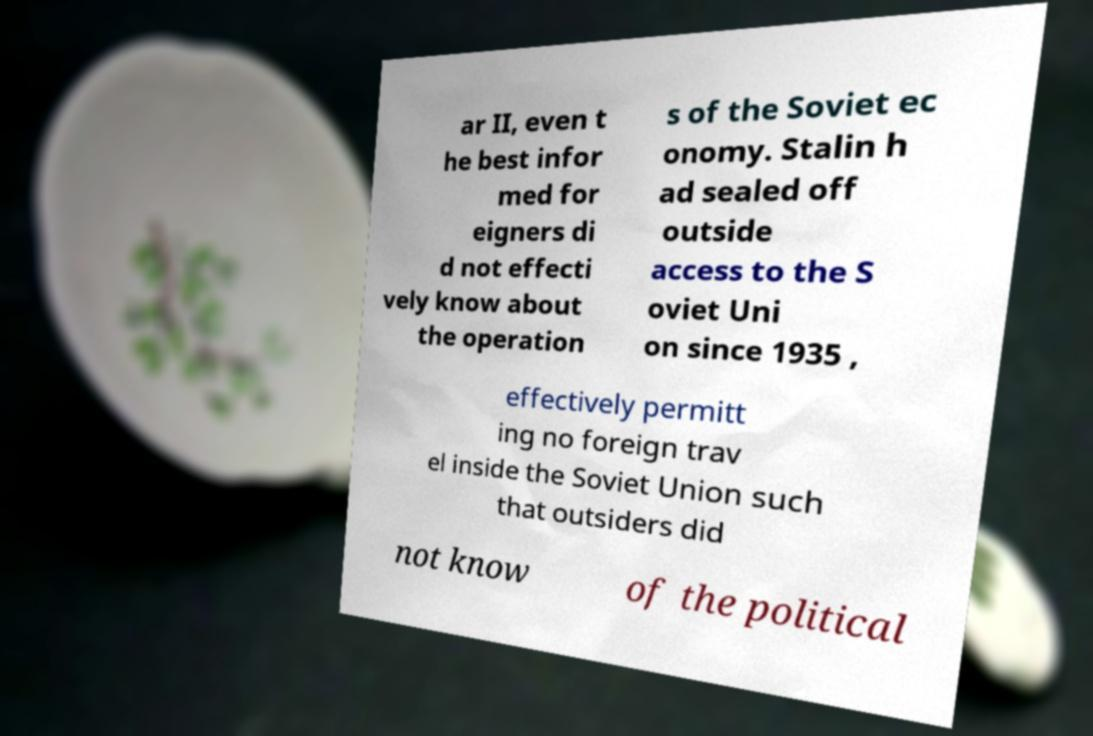Can you read and provide the text displayed in the image?This photo seems to have some interesting text. Can you extract and type it out for me? ar II, even t he best infor med for eigners di d not effecti vely know about the operation s of the Soviet ec onomy. Stalin h ad sealed off outside access to the S oviet Uni on since 1935 , effectively permitt ing no foreign trav el inside the Soviet Union such that outsiders did not know of the political 